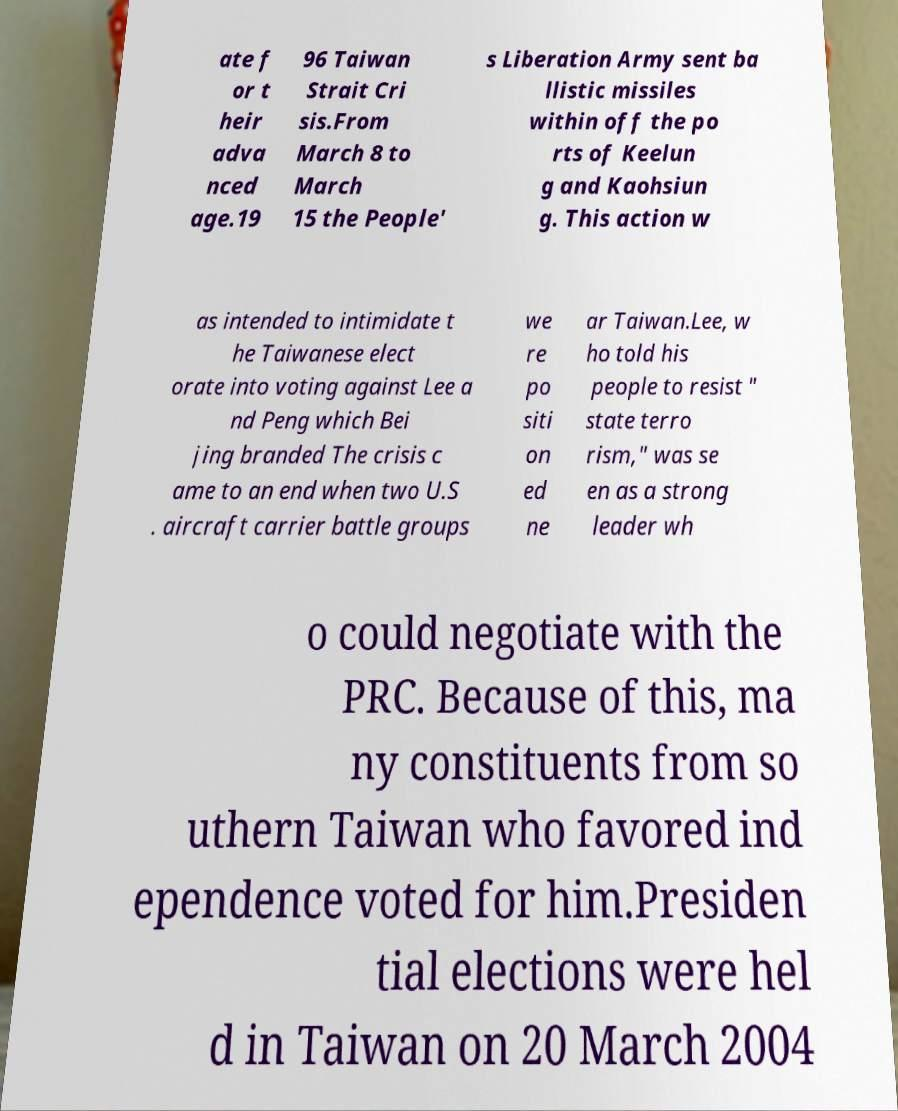What messages or text are displayed in this image? I need them in a readable, typed format. ate f or t heir adva nced age.19 96 Taiwan Strait Cri sis.From March 8 to March 15 the People' s Liberation Army sent ba llistic missiles within off the po rts of Keelun g and Kaohsiun g. This action w as intended to intimidate t he Taiwanese elect orate into voting against Lee a nd Peng which Bei jing branded The crisis c ame to an end when two U.S . aircraft carrier battle groups we re po siti on ed ne ar Taiwan.Lee, w ho told his people to resist " state terro rism," was se en as a strong leader wh o could negotiate with the PRC. Because of this, ma ny constituents from so uthern Taiwan who favored ind ependence voted for him.Presiden tial elections were hel d in Taiwan on 20 March 2004 